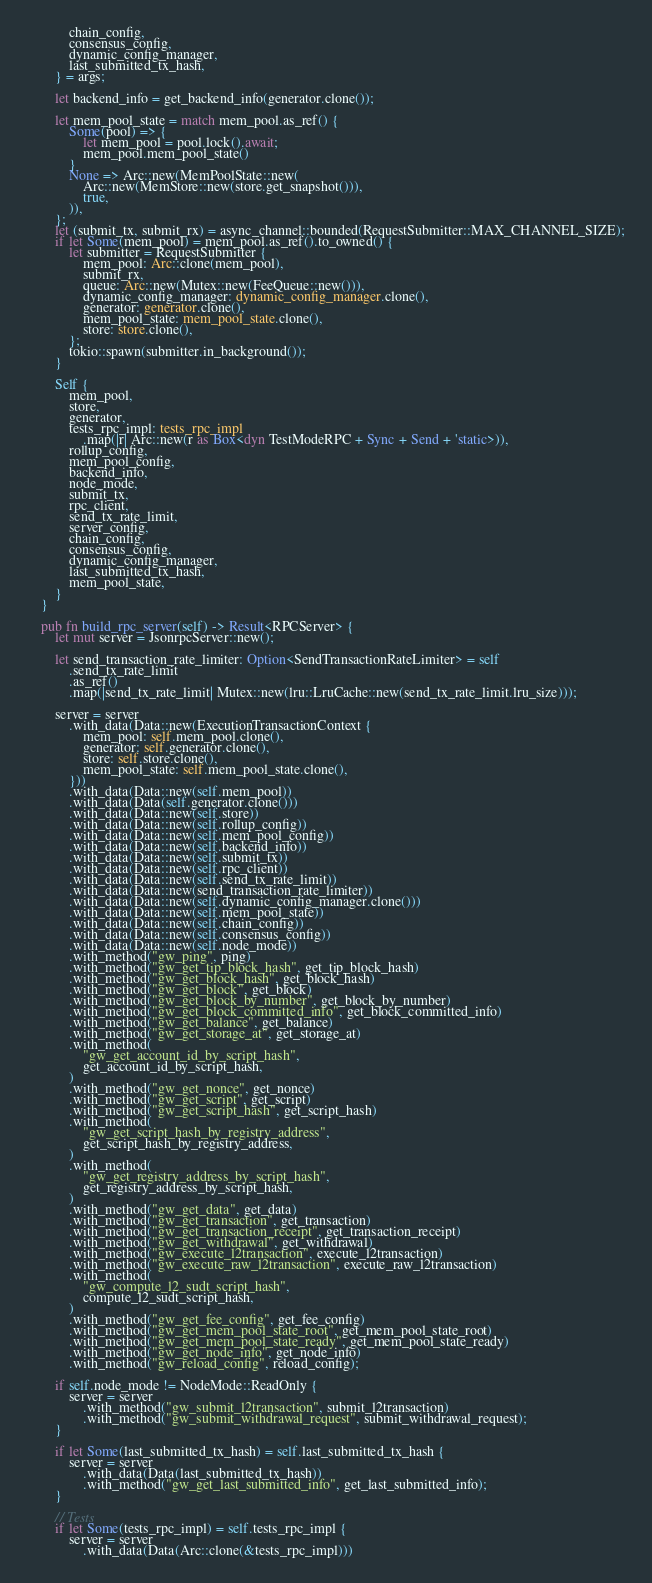Convert code to text. <code><loc_0><loc_0><loc_500><loc_500><_Rust_>            chain_config,
            consensus_config,
            dynamic_config_manager,
            last_submitted_tx_hash,
        } = args;

        let backend_info = get_backend_info(generator.clone());

        let mem_pool_state = match mem_pool.as_ref() {
            Some(pool) => {
                let mem_pool = pool.lock().await;
                mem_pool.mem_pool_state()
            }
            None => Arc::new(MemPoolState::new(
                Arc::new(MemStore::new(store.get_snapshot())),
                true,
            )),
        };
        let (submit_tx, submit_rx) = async_channel::bounded(RequestSubmitter::MAX_CHANNEL_SIZE);
        if let Some(mem_pool) = mem_pool.as_ref().to_owned() {
            let submitter = RequestSubmitter {
                mem_pool: Arc::clone(mem_pool),
                submit_rx,
                queue: Arc::new(Mutex::new(FeeQueue::new())),
                dynamic_config_manager: dynamic_config_manager.clone(),
                generator: generator.clone(),
                mem_pool_state: mem_pool_state.clone(),
                store: store.clone(),
            };
            tokio::spawn(submitter.in_background());
        }

        Self {
            mem_pool,
            store,
            generator,
            tests_rpc_impl: tests_rpc_impl
                .map(|r| Arc::new(r as Box<dyn TestModeRPC + Sync + Send + 'static>)),
            rollup_config,
            mem_pool_config,
            backend_info,
            node_mode,
            submit_tx,
            rpc_client,
            send_tx_rate_limit,
            server_config,
            chain_config,
            consensus_config,
            dynamic_config_manager,
            last_submitted_tx_hash,
            mem_pool_state,
        }
    }

    pub fn build_rpc_server(self) -> Result<RPCServer> {
        let mut server = JsonrpcServer::new();

        let send_transaction_rate_limiter: Option<SendTransactionRateLimiter> = self
            .send_tx_rate_limit
            .as_ref()
            .map(|send_tx_rate_limit| Mutex::new(lru::LruCache::new(send_tx_rate_limit.lru_size)));

        server = server
            .with_data(Data::new(ExecutionTransactionContext {
                mem_pool: self.mem_pool.clone(),
                generator: self.generator.clone(),
                store: self.store.clone(),
                mem_pool_state: self.mem_pool_state.clone(),
            }))
            .with_data(Data::new(self.mem_pool))
            .with_data(Data(self.generator.clone()))
            .with_data(Data::new(self.store))
            .with_data(Data::new(self.rollup_config))
            .with_data(Data::new(self.mem_pool_config))
            .with_data(Data::new(self.backend_info))
            .with_data(Data::new(self.submit_tx))
            .with_data(Data::new(self.rpc_client))
            .with_data(Data::new(self.send_tx_rate_limit))
            .with_data(Data::new(send_transaction_rate_limiter))
            .with_data(Data::new(self.dynamic_config_manager.clone()))
            .with_data(Data::new(self.mem_pool_state))
            .with_data(Data::new(self.chain_config))
            .with_data(Data::new(self.consensus_config))
            .with_data(Data::new(self.node_mode))
            .with_method("gw_ping", ping)
            .with_method("gw_get_tip_block_hash", get_tip_block_hash)
            .with_method("gw_get_block_hash", get_block_hash)
            .with_method("gw_get_block", get_block)
            .with_method("gw_get_block_by_number", get_block_by_number)
            .with_method("gw_get_block_committed_info", get_block_committed_info)
            .with_method("gw_get_balance", get_balance)
            .with_method("gw_get_storage_at", get_storage_at)
            .with_method(
                "gw_get_account_id_by_script_hash",
                get_account_id_by_script_hash,
            )
            .with_method("gw_get_nonce", get_nonce)
            .with_method("gw_get_script", get_script)
            .with_method("gw_get_script_hash", get_script_hash)
            .with_method(
                "gw_get_script_hash_by_registry_address",
                get_script_hash_by_registry_address,
            )
            .with_method(
                "gw_get_registry_address_by_script_hash",
                get_registry_address_by_script_hash,
            )
            .with_method("gw_get_data", get_data)
            .with_method("gw_get_transaction", get_transaction)
            .with_method("gw_get_transaction_receipt", get_transaction_receipt)
            .with_method("gw_get_withdrawal", get_withdrawal)
            .with_method("gw_execute_l2transaction", execute_l2transaction)
            .with_method("gw_execute_raw_l2transaction", execute_raw_l2transaction)
            .with_method(
                "gw_compute_l2_sudt_script_hash",
                compute_l2_sudt_script_hash,
            )
            .with_method("gw_get_fee_config", get_fee_config)
            .with_method("gw_get_mem_pool_state_root", get_mem_pool_state_root)
            .with_method("gw_get_mem_pool_state_ready", get_mem_pool_state_ready)
            .with_method("gw_get_node_info", get_node_info)
            .with_method("gw_reload_config", reload_config);

        if self.node_mode != NodeMode::ReadOnly {
            server = server
                .with_method("gw_submit_l2transaction", submit_l2transaction)
                .with_method("gw_submit_withdrawal_request", submit_withdrawal_request);
        }

        if let Some(last_submitted_tx_hash) = self.last_submitted_tx_hash {
            server = server
                .with_data(Data(last_submitted_tx_hash))
                .with_method("gw_get_last_submitted_info", get_last_submitted_info);
        }

        // Tests
        if let Some(tests_rpc_impl) = self.tests_rpc_impl {
            server = server
                .with_data(Data(Arc::clone(&tests_rpc_impl)))</code> 